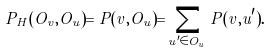Convert formula to latex. <formula><loc_0><loc_0><loc_500><loc_500>P _ { H } ( O _ { v } , O _ { u } ) = P ( v , O _ { u } ) = \sum _ { u ^ { \prime } \in O _ { u } } P ( v , u ^ { \prime } ) .</formula> 